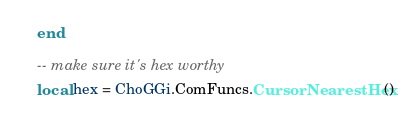<code> <loc_0><loc_0><loc_500><loc_500><_Lua_>	end

	-- make sure it's hex worthy
	local hex = ChoGGi.ComFuncs.CursorNearestHex()</code> 